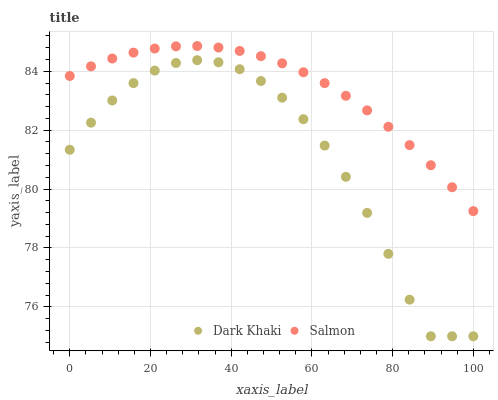Does Dark Khaki have the minimum area under the curve?
Answer yes or no. Yes. Does Salmon have the maximum area under the curve?
Answer yes or no. Yes. Does Salmon have the minimum area under the curve?
Answer yes or no. No. Is Salmon the smoothest?
Answer yes or no. Yes. Is Dark Khaki the roughest?
Answer yes or no. Yes. Is Salmon the roughest?
Answer yes or no. No. Does Dark Khaki have the lowest value?
Answer yes or no. Yes. Does Salmon have the lowest value?
Answer yes or no. No. Does Salmon have the highest value?
Answer yes or no. Yes. Is Dark Khaki less than Salmon?
Answer yes or no. Yes. Is Salmon greater than Dark Khaki?
Answer yes or no. Yes. Does Dark Khaki intersect Salmon?
Answer yes or no. No. 